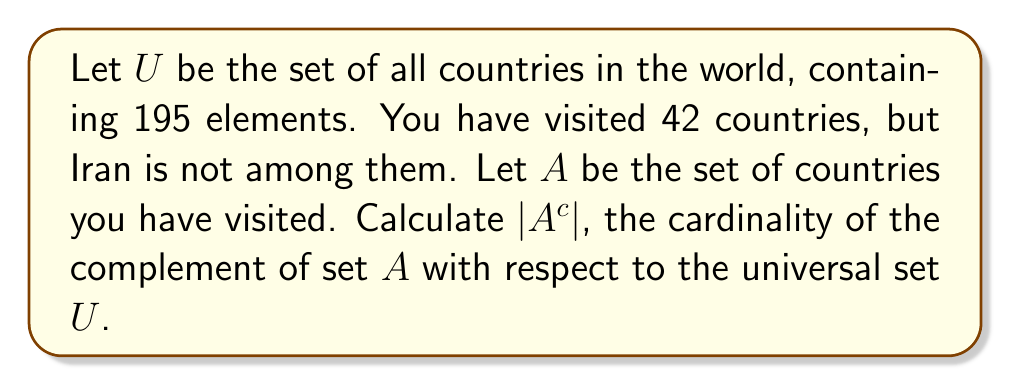Show me your answer to this math problem. To solve this problem, we need to follow these steps:

1. Understand the given information:
   - $U$ is the universal set of all countries, $|U| = 195$
   - $A$ is the set of countries visited, $|A| = 42$
   - Iran is not in set $A$

2. Recall the definition of complement:
   The complement of set $A$ with respect to universal set $U$, denoted as $A^c$, is the set of all elements in $U$ that are not in $A$.

3. Use the relationship between a set and its complement:
   For any set $A$ in a universal set $U$, we have:
   $$|U| = |A| + |A^c|$$

4. Solve for $|A^c|$:
   $$|A^c| = |U| - |A|$$
   $$|A^c| = 195 - 42$$
   $$|A^c| = 153$$

Therefore, the cardinality of the complement of set $A$ is 153, representing the number of countries you haven't visited.
Answer: $|A^c| = 153$ 